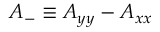Convert formula to latex. <formula><loc_0><loc_0><loc_500><loc_500>A _ { - } \equiv A _ { y y } - A _ { x x }</formula> 